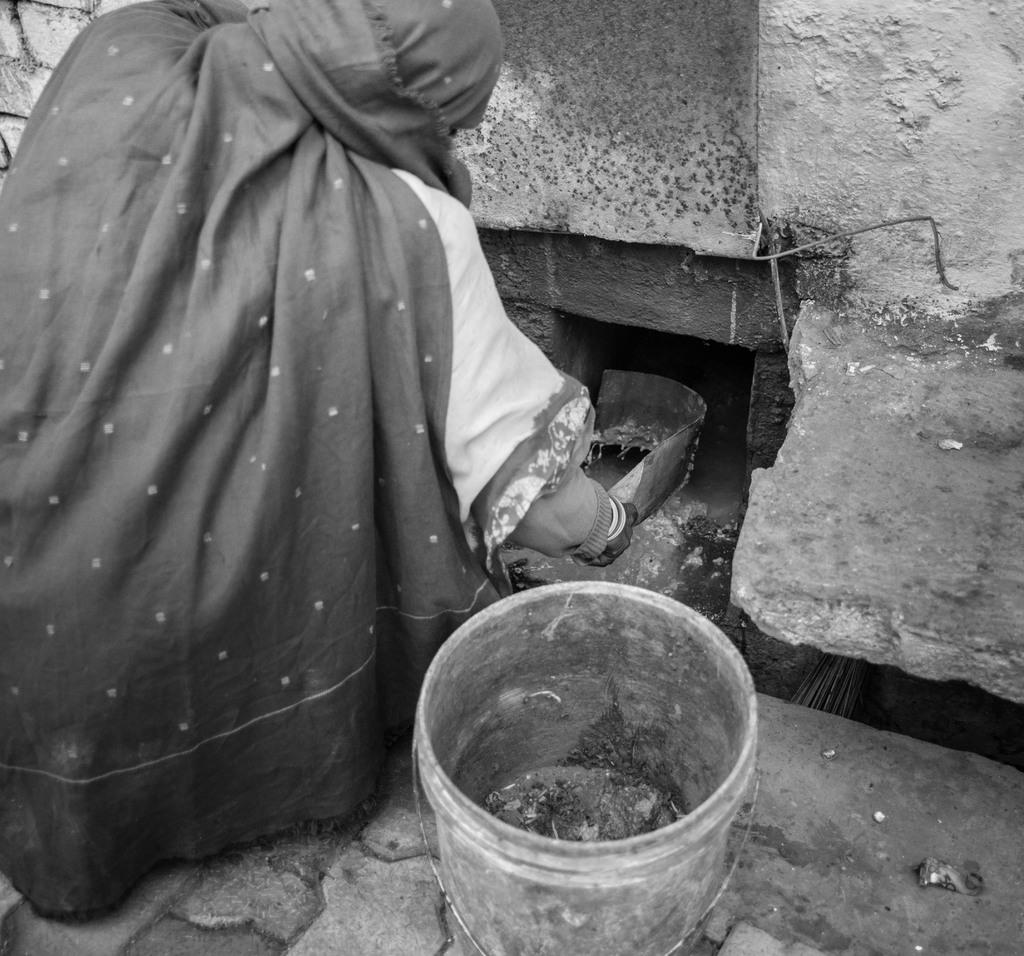What is the person in the image holding? The person is holding something in the image. What object is in front of the person? There is a bucket in front of the person. What is the background of the image? There is a wall in front of the person. What color scheme is used in the image? The image is in black and white. What type of government is depicted in the image? There is no depiction of a government in the image; it features a person holding something, a bucket, and a wall. What part of the field can be seen in the image? There is no field present in the image; it is set against a wall. 